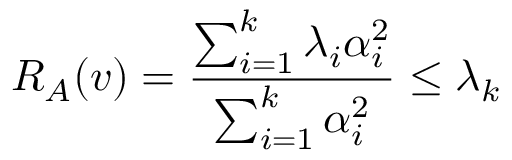Convert formula to latex. <formula><loc_0><loc_0><loc_500><loc_500>R _ { A } ( v ) = { \frac { \sum _ { i = 1 } ^ { k } \lambda _ { i } \alpha _ { i } ^ { 2 } } { \sum _ { i = 1 } ^ { k } \alpha _ { i } ^ { 2 } } } \leq \lambda _ { k }</formula> 